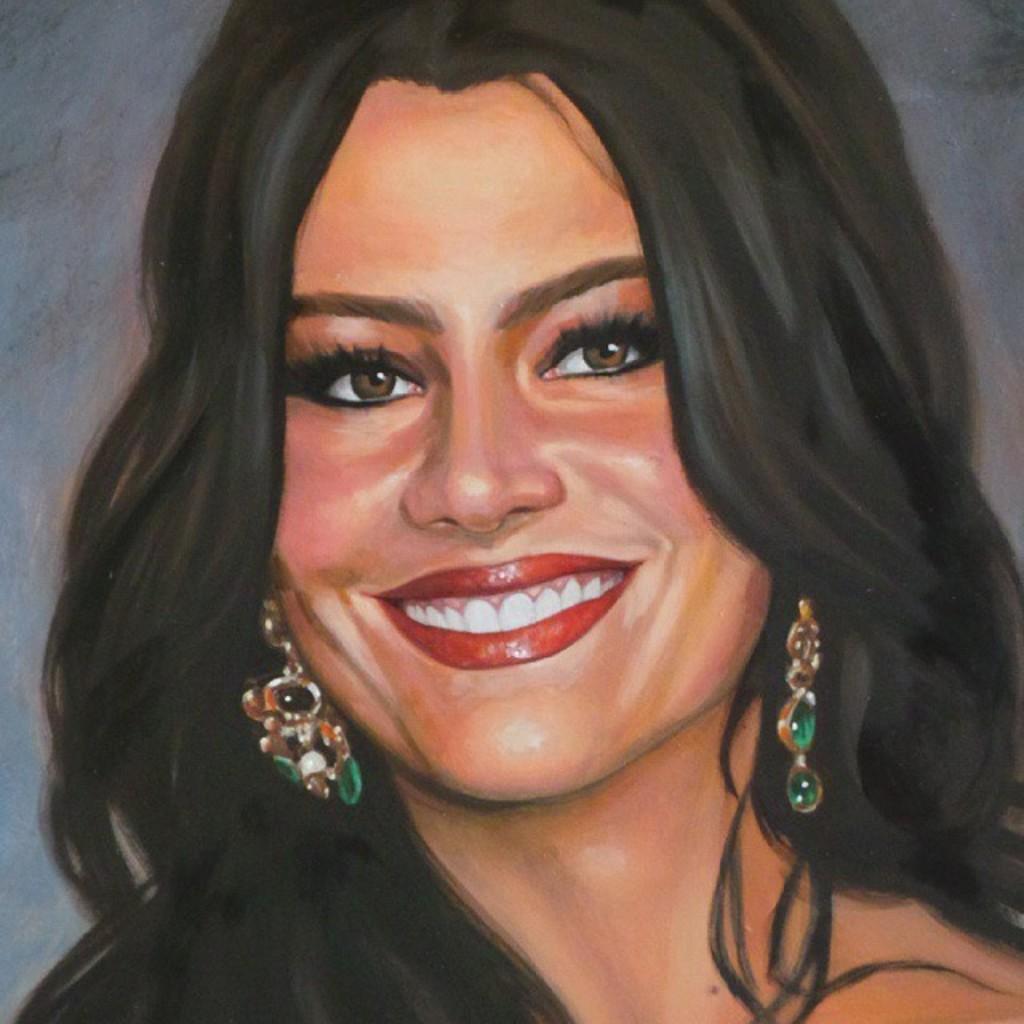Could you give a brief overview of what you see in this image? In this picture there is a painting of a woman. She is smiling and wearing earrings. 